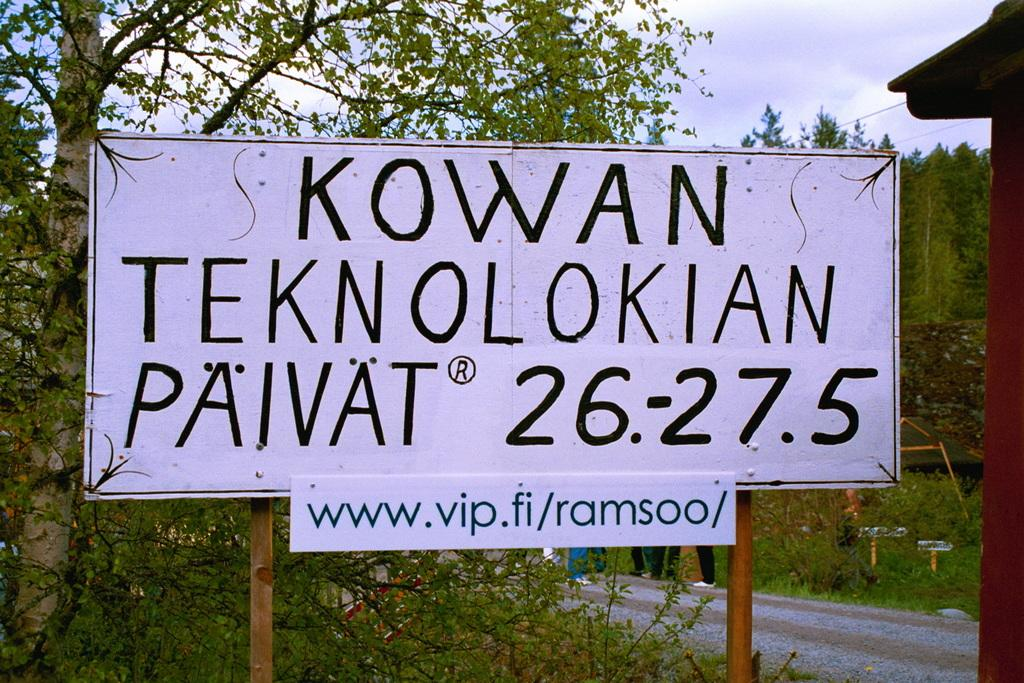What is on the board that is visible in the image? There is a board with text in the image. What type of vegetation is present in the image? There are plants and trees in the image. What can be seen in the background of the image? There are people standing in the background of the image. What is visible at the top of the image? The sky is visible at the top of the image. Can you hear the cat sneezing in the image? There is no cat present in the image, and therefore no sneezing can be heard. Is it raining in the image? The provided facts do not mention rain, and there is no indication of rain in the image. 